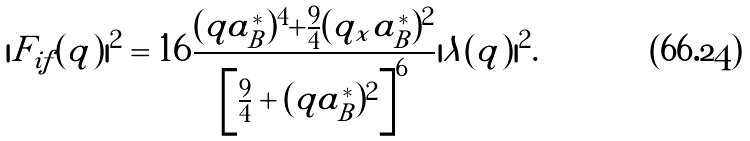Convert formula to latex. <formula><loc_0><loc_0><loc_500><loc_500>| F _ { i f } ( { q } ) | ^ { 2 } = 1 6 \frac { ( q a _ { B } ^ { * } ) ^ { 4 } + \frac { 9 } { 4 } ( q _ { x } a _ { B } ^ { * } ) ^ { 2 } } { \left [ \frac { 9 } { 4 } + ( q a _ { B } ^ { * } ) ^ { 2 } \right ] ^ { 6 } } | \lambda ( { q } ) | ^ { 2 } .</formula> 